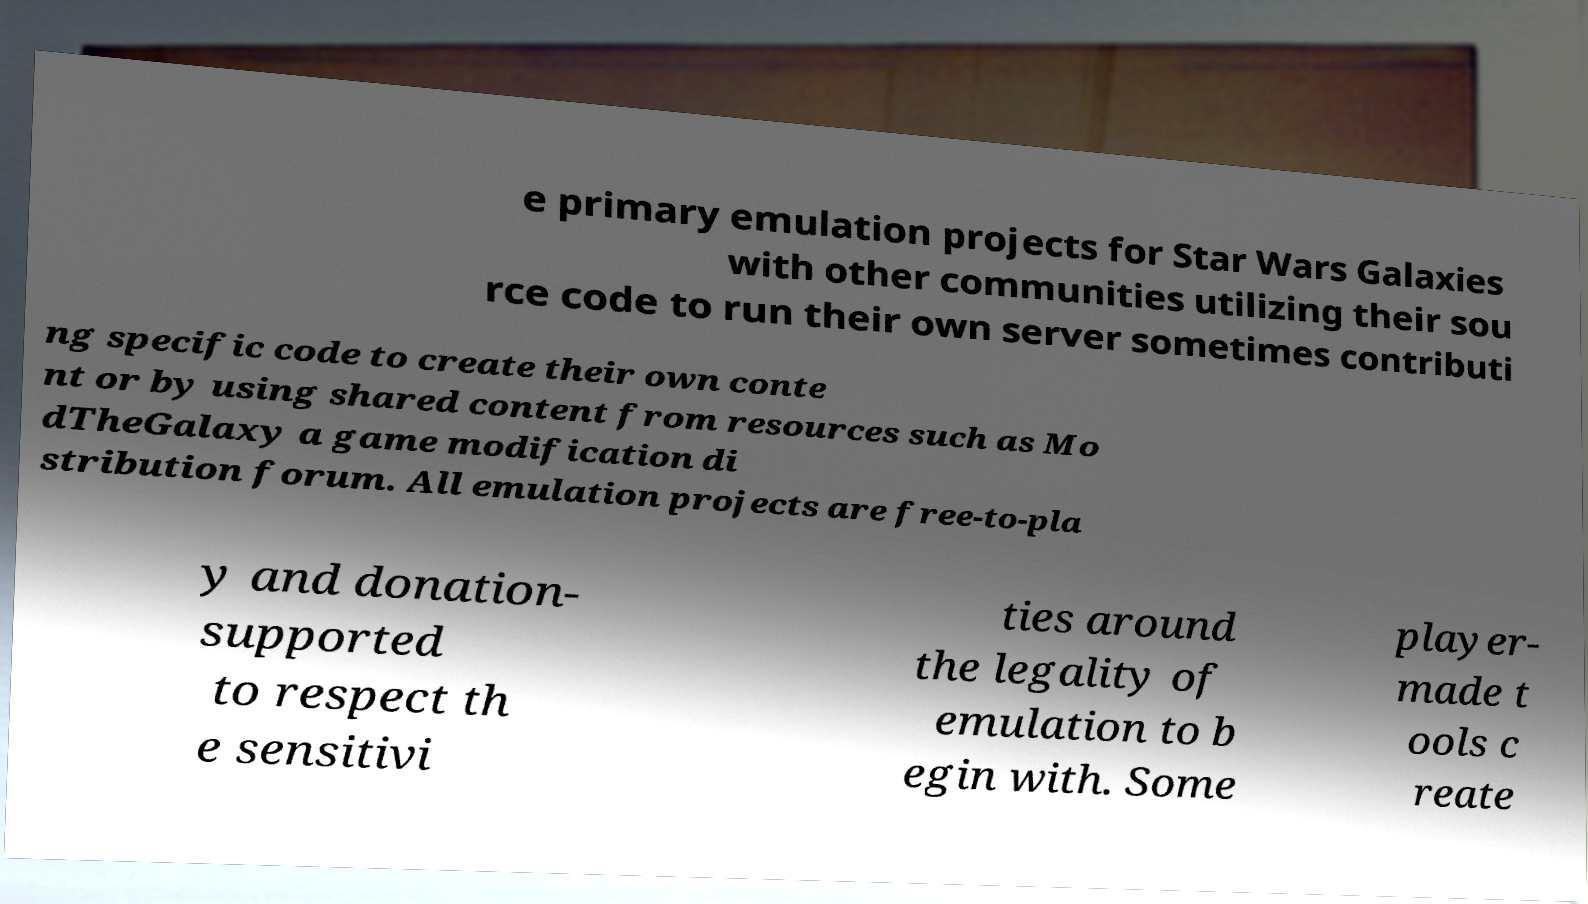Could you assist in decoding the text presented in this image and type it out clearly? e primary emulation projects for Star Wars Galaxies with other communities utilizing their sou rce code to run their own server sometimes contributi ng specific code to create their own conte nt or by using shared content from resources such as Mo dTheGalaxy a game modification di stribution forum. All emulation projects are free-to-pla y and donation- supported to respect th e sensitivi ties around the legality of emulation to b egin with. Some player- made t ools c reate 